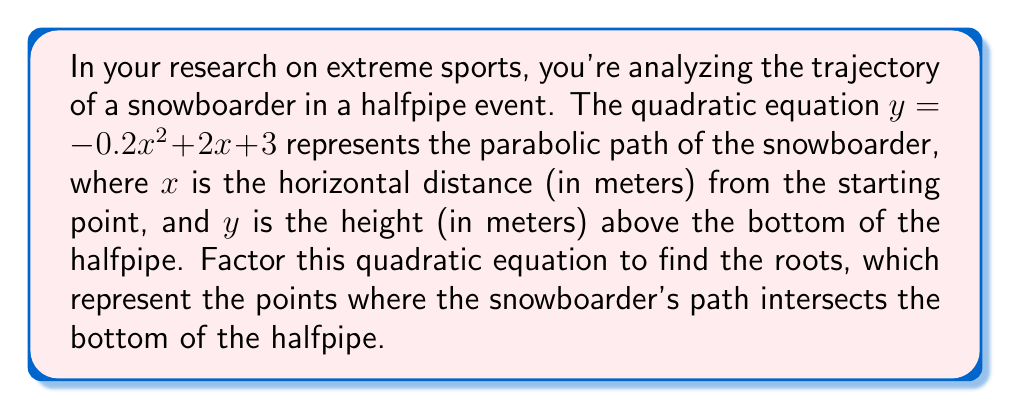Can you solve this math problem? To factor this quadratic equation, we'll follow these steps:

1) First, identify the coefficients:
   $a = -0.2$, $b = 2$, and $c = 3$

2) Use the quadratic formula: $x = \frac{-b \pm \sqrt{b^2 - 4ac}}{2a}$

3) Substitute the values:
   $$x = \frac{-2 \pm \sqrt{2^2 - 4(-0.2)(3)}}{2(-0.2)}$$

4) Simplify under the square root:
   $$x = \frac{-2 \pm \sqrt{4 + 2.4}}{-0.4} = \frac{-2 \pm \sqrt{6.4}}{-0.4}$$

5) Simplify further:
   $$x = \frac{-2 \pm 2.53}{-0.4}$$

6) Calculate the two roots:
   $$x_1 = \frac{-2 + 2.53}{-0.4} = \frac{0.53}{-0.4} = -1.325$$
   $$x_2 = \frac{-2 - 2.53}{-0.4} = \frac{-4.53}{-0.4} = 11.325$$

7) The factored form of the quadratic equation is:
   $$y = -0.2(x + 1.325)(x - 11.325)$$

This factored form shows that the snowboarder's path intersects the bottom of the halfpipe at approximately -1.325 meters and 11.325 meters from the starting point.
Answer: $y = -0.2(x + 1.325)(x - 11.325)$ 